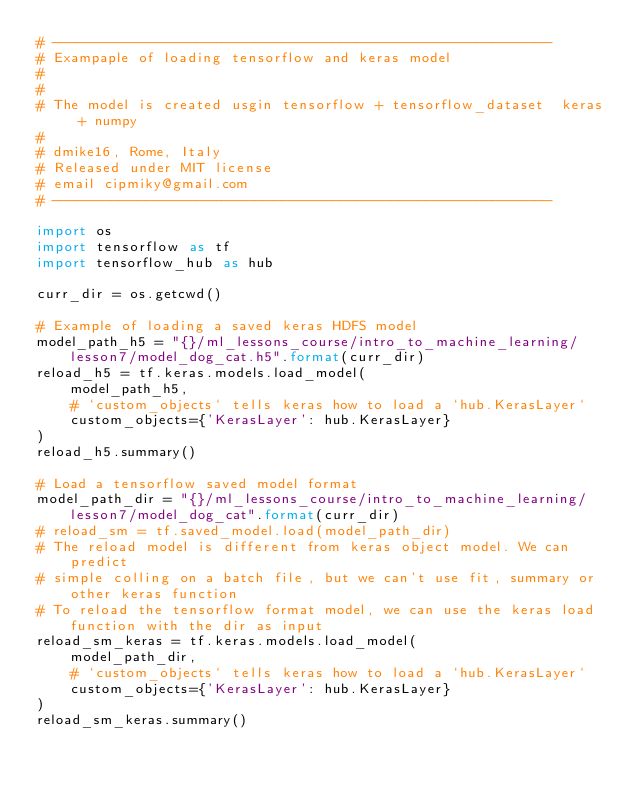Convert code to text. <code><loc_0><loc_0><loc_500><loc_500><_Python_># -----------------------------------------------------------
# Exampaple of loading tensorflow and keras model
#
#
# The model is created usgin tensorflow + tensorflow_dataset  keras + numpy
#
# dmike16, Rome, Italy
# Released under MIT license
# email cipmiky@gmail.com
# -----------------------------------------------------------

import os
import tensorflow as tf
import tensorflow_hub as hub

curr_dir = os.getcwd()

# Example of loading a saved keras HDFS model
model_path_h5 = "{}/ml_lessons_course/intro_to_machine_learning/lesson7/model_dog_cat.h5".format(curr_dir)
reload_h5 = tf.keras.models.load_model(
    model_path_h5,
    # `custom_objects` tells keras how to load a `hub.KerasLayer`
    custom_objects={'KerasLayer': hub.KerasLayer}
)
reload_h5.summary()

# Load a tensorflow saved model format
model_path_dir = "{}/ml_lessons_course/intro_to_machine_learning/lesson7/model_dog_cat".format(curr_dir)
# reload_sm = tf.saved_model.load(model_path_dir)
# The reload model is different from keras object model. We can predict
# simple colling on a batch file, but we can't use fit, summary or other keras function
# To reload the tensorflow format model, we can use the keras load function with the dir as input
reload_sm_keras = tf.keras.models.load_model(
    model_path_dir,
    # `custom_objects` tells keras how to load a `hub.KerasLayer`
    custom_objects={'KerasLayer': hub.KerasLayer}
)
reload_sm_keras.summary()
</code> 